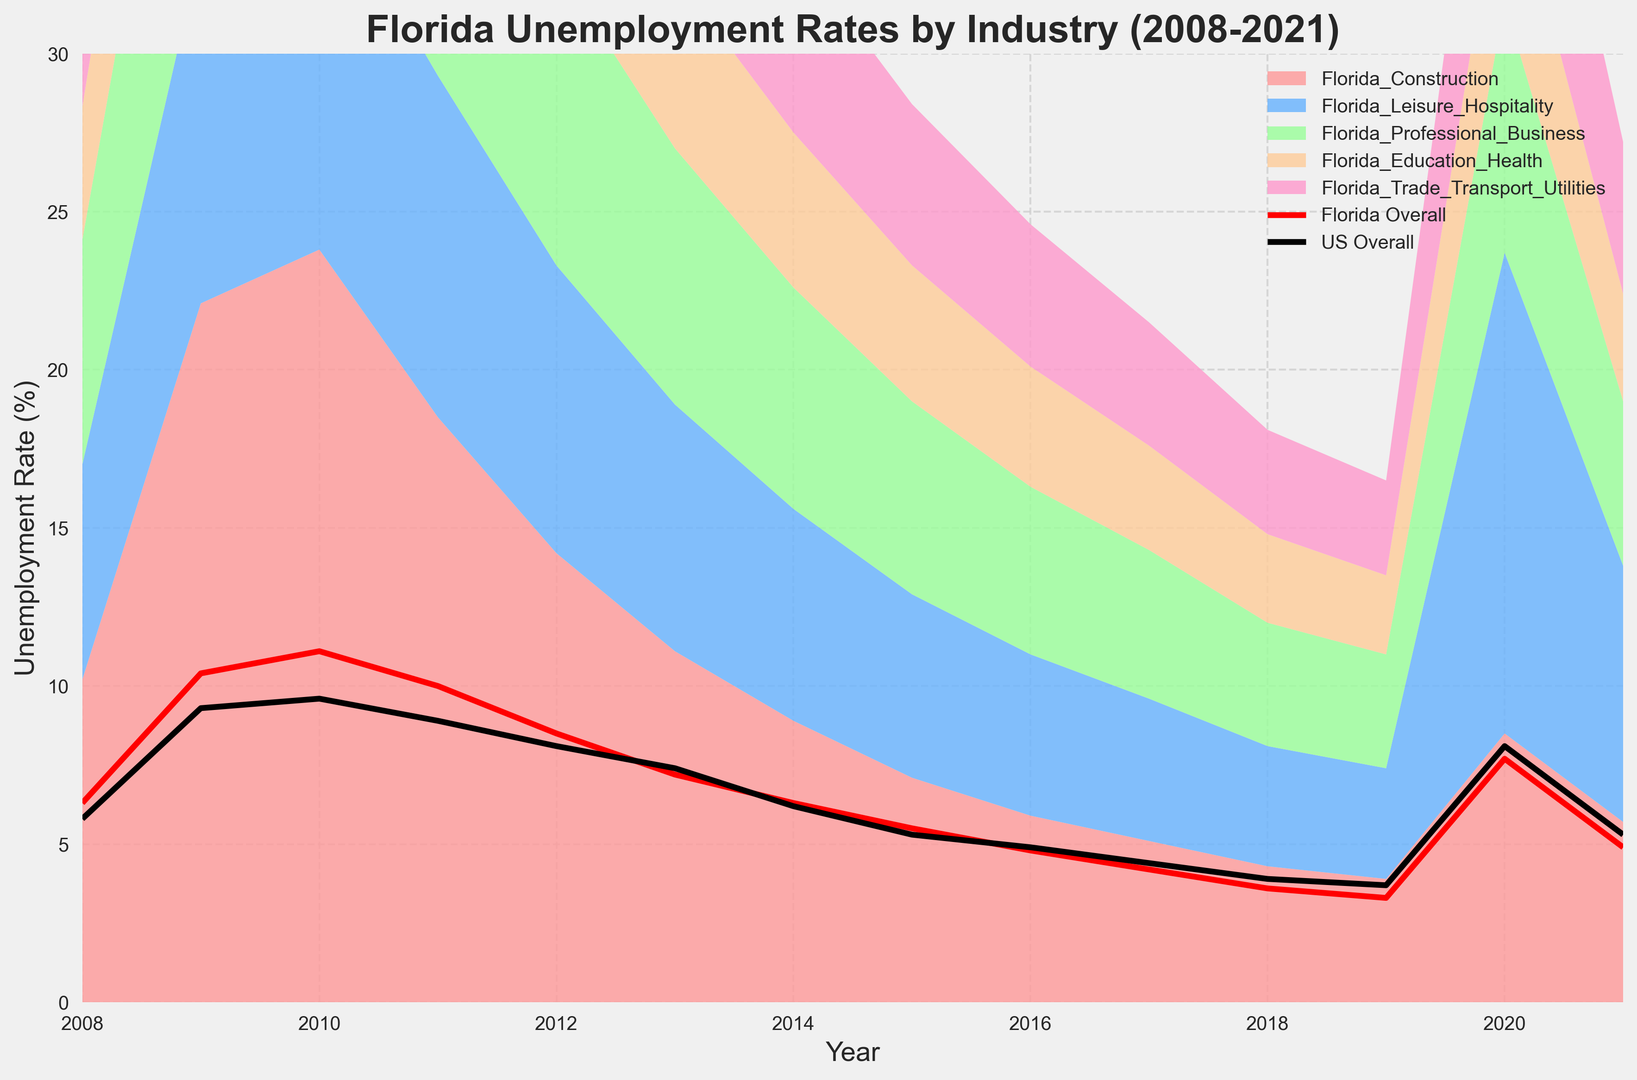What year did Florida's overall unemployment rate peak, and what was the rate? Look at the red line representing Florida's overall unemployment rate. The peak is noticeable visually.
Answer: 2010, 11.1% Which sector had the highest unemployment rate in 2010, and what was the rate? Identify the individual sector lines for 2010. The highest peak is for the construction sector.
Answer: Construction, 23.8% Compare Florida's overall unemployment rate to the national average in 2020. Which was higher, and by how much? Look at the plot lines for Florida overall and US overall in 2020. The US rate is slightly higher, subtract the Florida rate from the US rate.
Answer: US higher by 0.4% Which sector had the most significant decrease in unemployment rate between 2009 and 2019? Compare the peaks for each sector in 2009 and 2019. Calculate the rate of decrease for each sector and identify the largest.
Answer: Construction In which year did the Leisure & Hospitality sector see the highest unemployment rate, and what was the rate? Look for the Leisure & Hospitality line on the area chart and identify the highest peak.
Answer: 2020, 15.2% Which sector consistently had a lower unemployment rate compared to the Florida overall rate each year? Compare each sector's line to the overall Florida line for all years. Identify the sector that stays below the overall rate consistently.
Answer: Education & Health How did the unemployment rate for Florida's Trade, Transport & Utilities sector in 2010 compare to the national overall rate that year? Compare the Trade, Transport & Utilities sector line in 2010 to the national overall line in the same year. The rates are closely aligned but slightly different.
Answer: Higher by 1.2% Which two sectors had the closest unemployment rates in 2019? Compare the sector lines for 2019 and identify the two with the smallest difference.
Answer: Professional Business and Trade, Transport & Utilities By what percentage did Florida's overall unemployment rate decrease from its peak in 2010 to its lowest point in 2019? Calculate the percentage decrease from 11.1% (2010) to 3.3% (2019): ((11.1 - 3.3)/11.1) * 100% ≈ 70.3%.
Answer: 70.3% Which year shows Florida's Construction sector's unemployment rate lower than 10%, and did it happen again before 2021? Identify the year(s) where the Construction sector line dipped below 10%. Note if it repeated before 2021.
Answer: 2014, repeated multiple times 